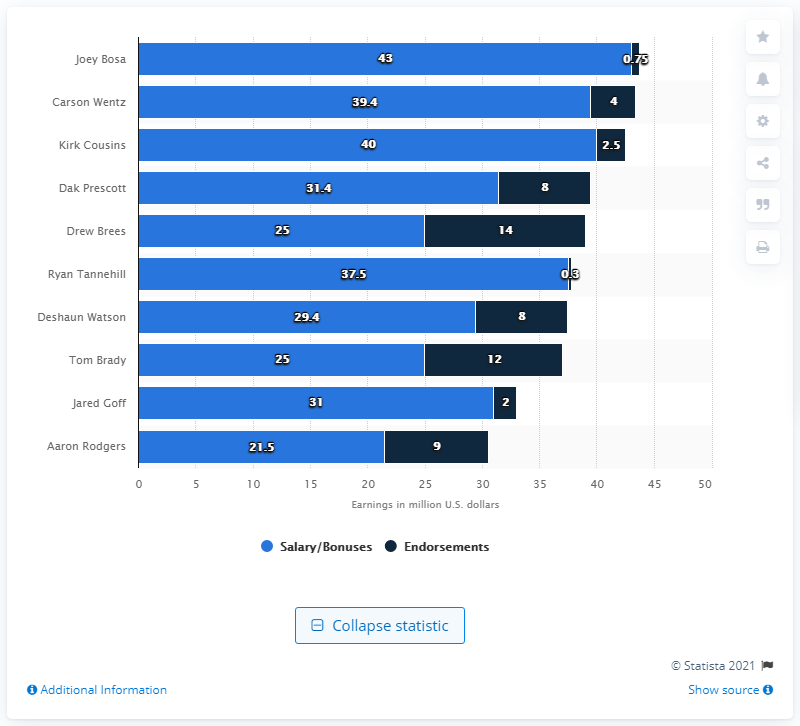Identify some key points in this picture. Joey Bosa earned a total of $43 from his salary and bonuses. Joey Bosa earned approximately 0.75 million dollars from endorsement deals. 